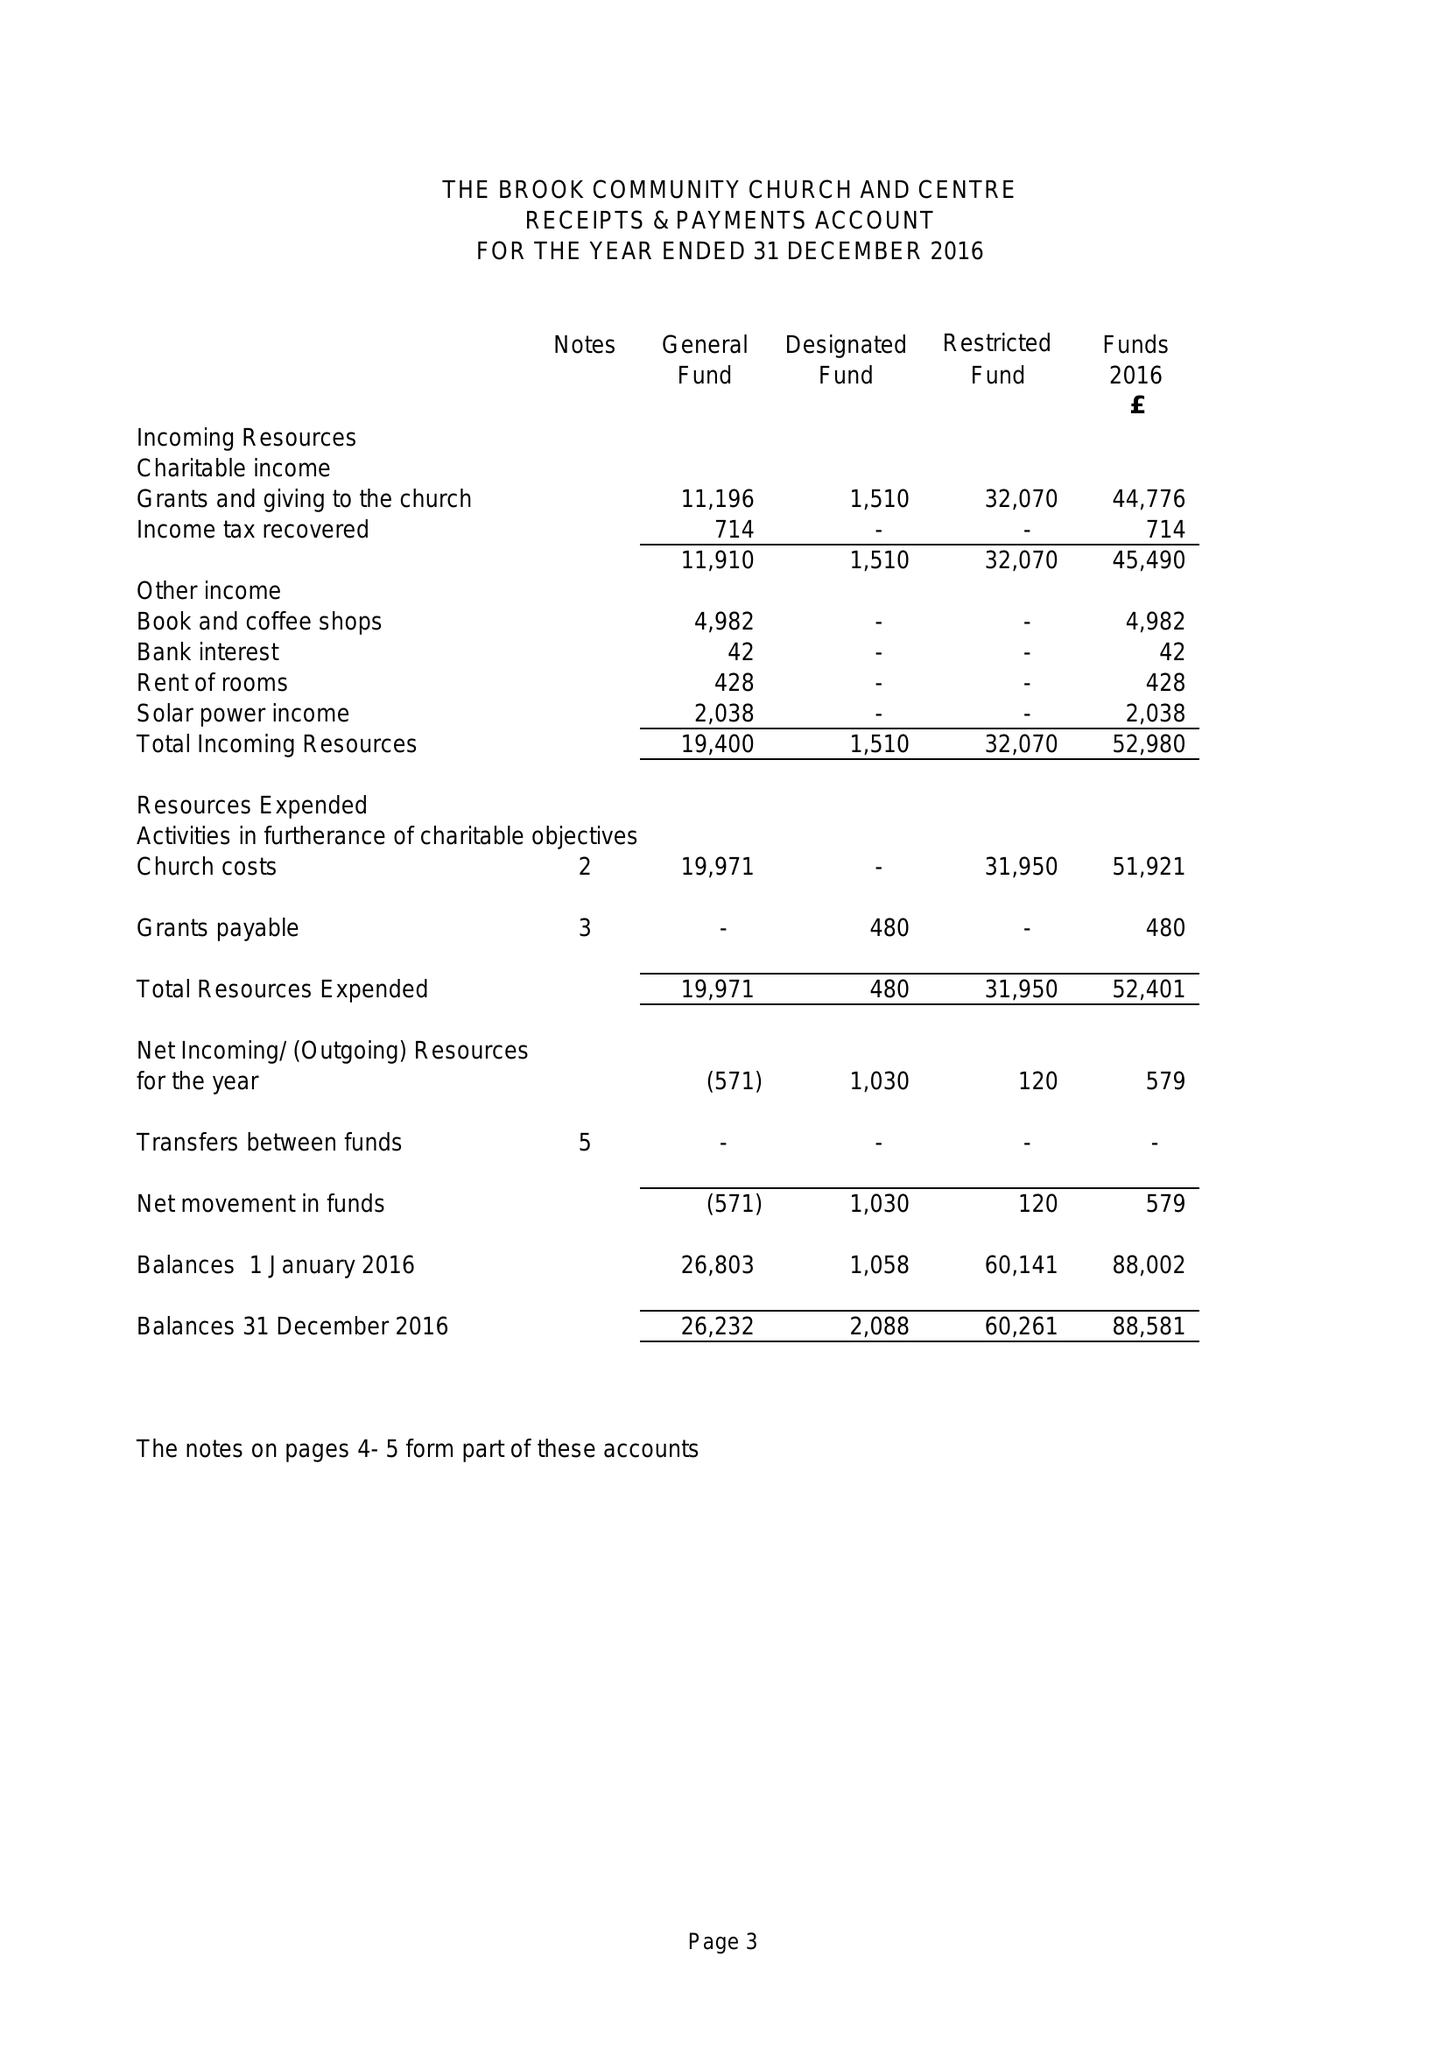What is the value for the spending_annually_in_british_pounds?
Answer the question using a single word or phrase. 52241.00 